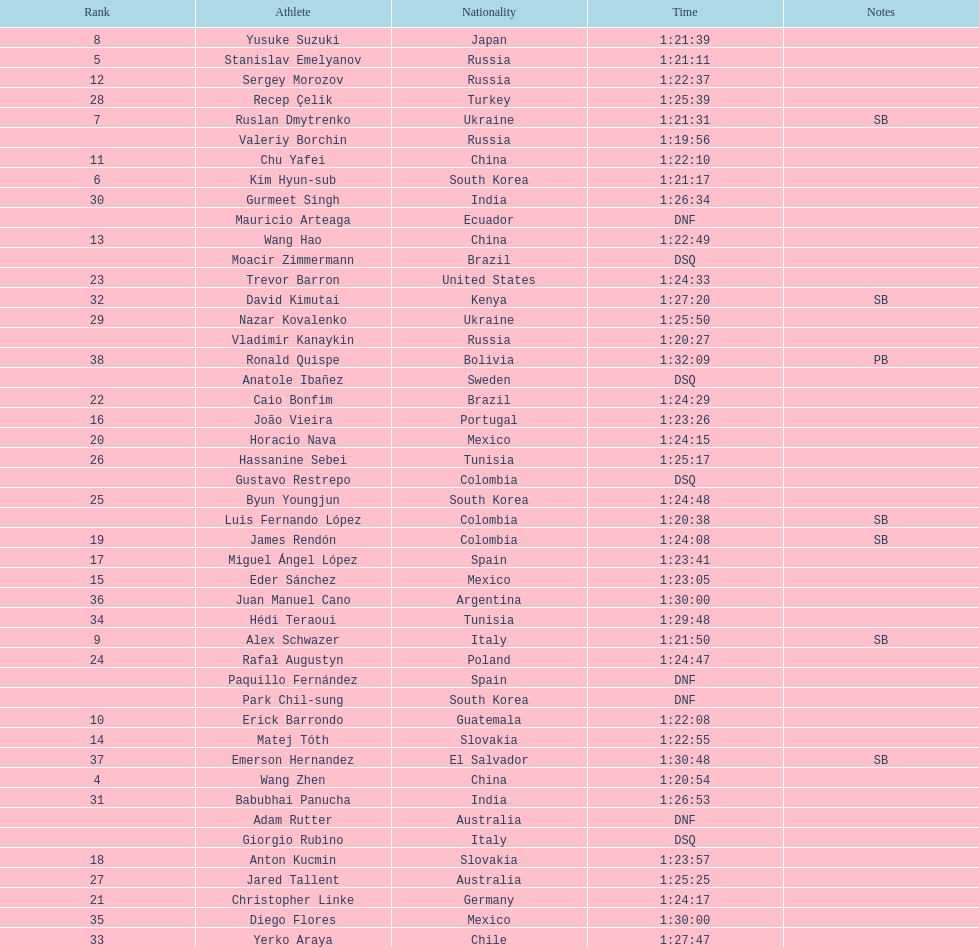What is the total count of athletes included in the rankings chart, including those classified as dsq & dnf? 46. 